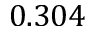Convert formula to latex. <formula><loc_0><loc_0><loc_500><loc_500>0 . 3 0 4</formula> 